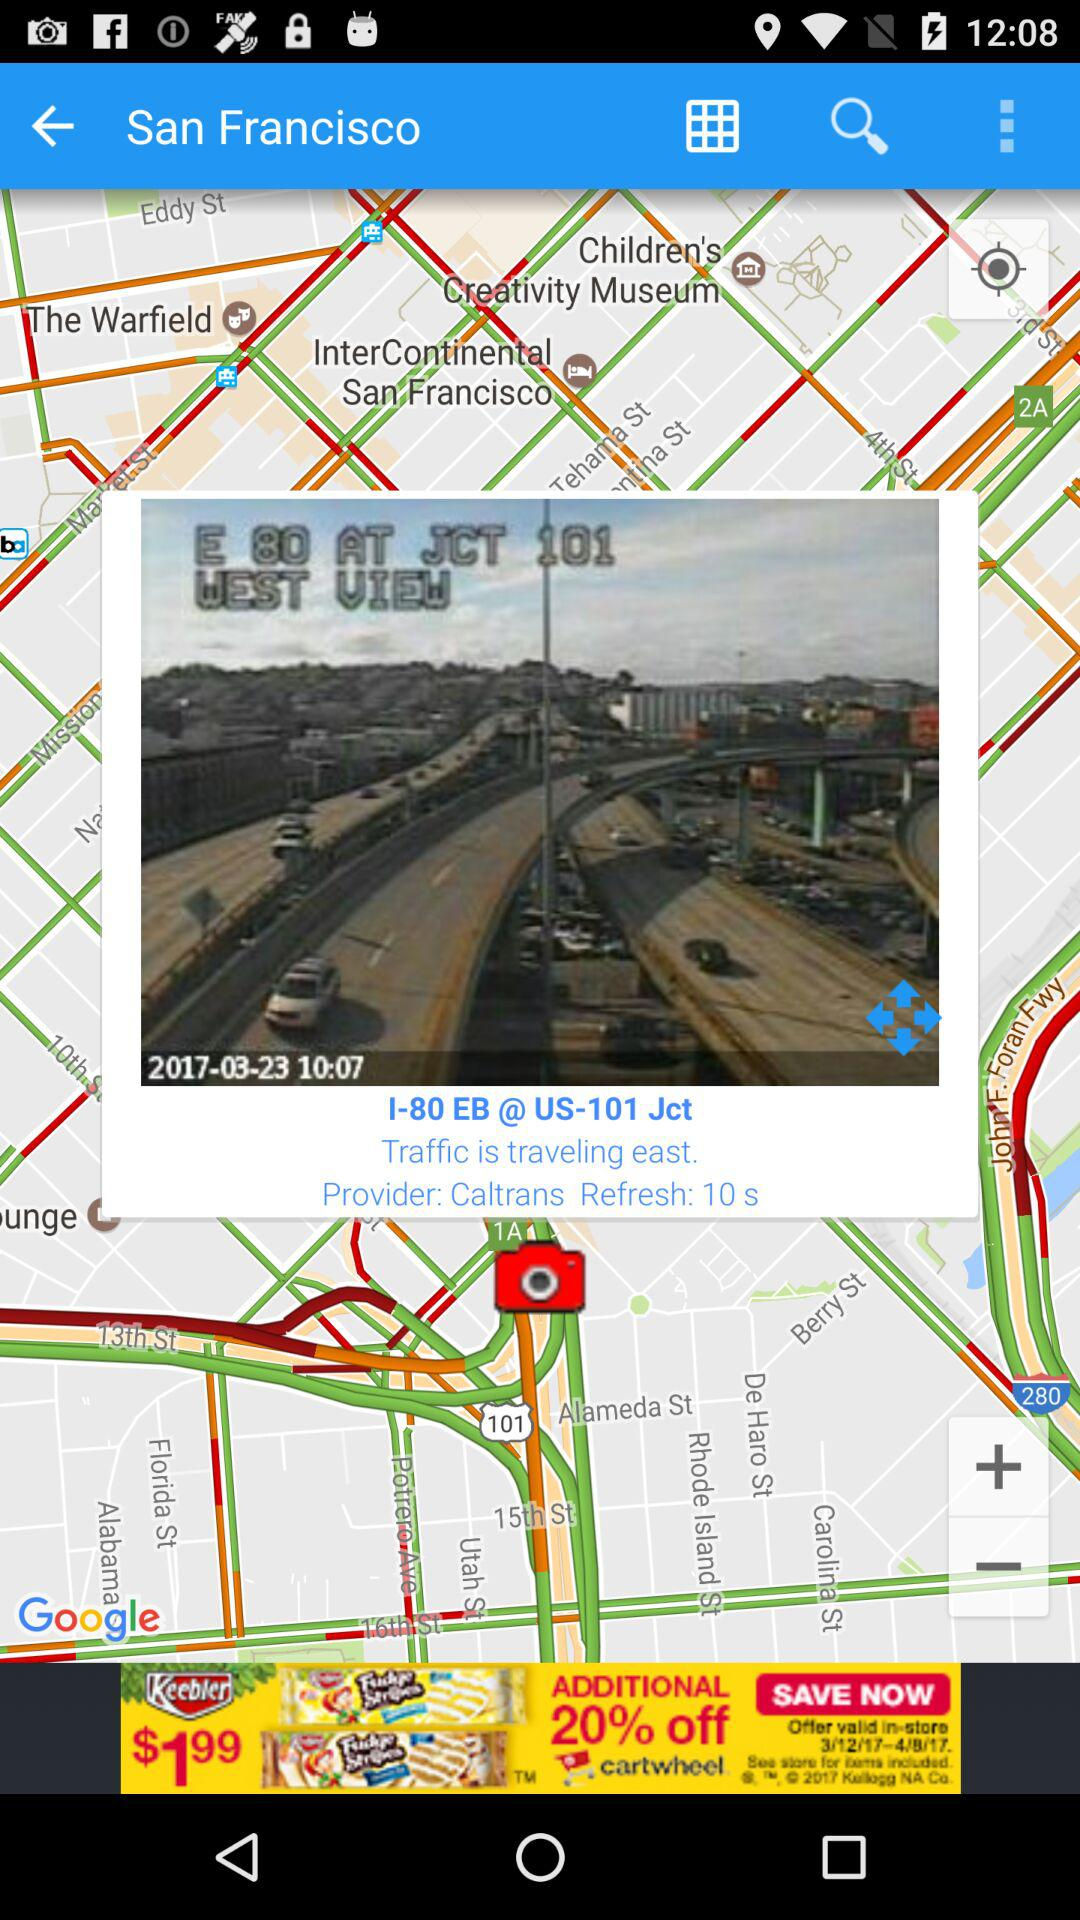What is the refresh time? The refresh time is 10 seconds. 